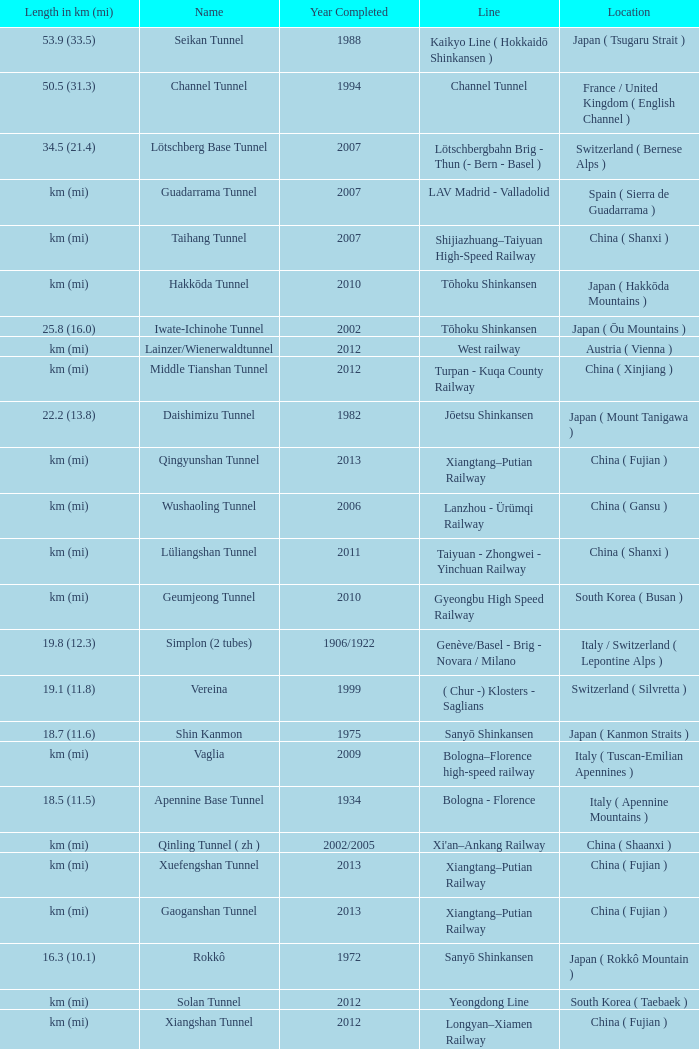Which line is the Geumjeong tunnel? Gyeongbu High Speed Railway. Parse the full table. {'header': ['Length in km (mi)', 'Name', 'Year Completed', 'Line', 'Location'], 'rows': [['53.9 (33.5)', 'Seikan Tunnel', '1988', 'Kaikyo Line ( Hokkaidō Shinkansen )', 'Japan ( Tsugaru Strait )'], ['50.5 (31.3)', 'Channel Tunnel', '1994', 'Channel Tunnel', 'France / United Kingdom ( English Channel )'], ['34.5 (21.4)', 'Lötschberg Base Tunnel', '2007', 'Lötschbergbahn Brig - Thun (- Bern - Basel )', 'Switzerland ( Bernese Alps )'], ['km (mi)', 'Guadarrama Tunnel', '2007', 'LAV Madrid - Valladolid', 'Spain ( Sierra de Guadarrama )'], ['km (mi)', 'Taihang Tunnel', '2007', 'Shijiazhuang–Taiyuan High-Speed Railway', 'China ( Shanxi )'], ['km (mi)', 'Hakkōda Tunnel', '2010', 'Tōhoku Shinkansen', 'Japan ( Hakkōda Mountains )'], ['25.8 (16.0)', 'Iwate-Ichinohe Tunnel', '2002', 'Tōhoku Shinkansen', 'Japan ( Ōu Mountains )'], ['km (mi)', 'Lainzer/Wienerwaldtunnel', '2012', 'West railway', 'Austria ( Vienna )'], ['km (mi)', 'Middle Tianshan Tunnel', '2012', 'Turpan - Kuqa County Railway', 'China ( Xinjiang )'], ['22.2 (13.8)', 'Daishimizu Tunnel', '1982', 'Jōetsu Shinkansen', 'Japan ( Mount Tanigawa )'], ['km (mi)', 'Qingyunshan Tunnel', '2013', 'Xiangtang–Putian Railway', 'China ( Fujian )'], ['km (mi)', 'Wushaoling Tunnel', '2006', 'Lanzhou - Ürümqi Railway', 'China ( Gansu )'], ['km (mi)', 'Lüliangshan Tunnel', '2011', 'Taiyuan - Zhongwei - Yinchuan Railway', 'China ( Shanxi )'], ['km (mi)', 'Geumjeong Tunnel', '2010', 'Gyeongbu High Speed Railway', 'South Korea ( Busan )'], ['19.8 (12.3)', 'Simplon (2 tubes)', '1906/1922', 'Genève/Basel - Brig - Novara / Milano', 'Italy / Switzerland ( Lepontine Alps )'], ['19.1 (11.8)', 'Vereina', '1999', '( Chur -) Klosters - Saglians', 'Switzerland ( Silvretta )'], ['18.7 (11.6)', 'Shin Kanmon', '1975', 'Sanyō Shinkansen', 'Japan ( Kanmon Straits )'], ['km (mi)', 'Vaglia', '2009', 'Bologna–Florence high-speed railway', 'Italy ( Tuscan-Emilian Apennines )'], ['18.5 (11.5)', 'Apennine Base Tunnel', '1934', 'Bologna - Florence', 'Italy ( Apennine Mountains )'], ['km (mi)', 'Qinling Tunnel ( zh )', '2002/2005', "Xi'an–Ankang Railway", 'China ( Shaanxi )'], ['km (mi)', 'Xuefengshan Tunnel', '2013', 'Xiangtang–Putian Railway', 'China ( Fujian )'], ['km (mi)', 'Gaoganshan Tunnel', '2013', 'Xiangtang–Putian Railway', 'China ( Fujian )'], ['16.3 (10.1)', 'Rokkô', '1972', 'Sanyō Shinkansen', 'Japan ( Rokkô Mountain )'], ['km (mi)', 'Solan Tunnel', '2012', 'Yeongdong Line', 'South Korea ( Taebaek )'], ['km (mi)', 'Xiangshan Tunnel', '2012', 'Longyan–Xiamen Railway', 'China ( Fujian )'], ['km (mi)', 'Daiyunshan Tunnel', '2013', 'Xiangtang–Putian Railway', 'China ( Fujian )'], ['km (mi)', 'Guanshan Tunnel', '2012', 'Tianshui - Pingliang Railway', 'China ( Gansu )'], ['15.4 (9.6)', 'Furka Base', '1982', 'Andermatt - Brig', 'Switzerland ( Urner Alps )'], ['15.4 (9.5)', 'Haruna', '1982', 'Jōetsu Shinkansen', 'Japan ( Gunma Prefecture )'], ['km (mi)', 'Firenzuola', '2009', 'Bologna–Florence high-speed railway', 'Italy ( Tuscan-Emilian Apennines )'], ['15.3 (9.5)', 'Severomuyskiy', '2001', 'Baikal Amur Mainline', 'Russia ( Severomuysky Range )'], ['15.2 (9.4)', 'Gorigamine', '1997', 'Nagano Shinkansen ( Hokuriku Shinkansen )', 'Japan ( Akaishi Mountains )'], ['km (mi)', 'Liulangshan Tunnel', '2012', 'Zhungeer - Shuozhou Railway', 'China ( Shanxi )'], ['15.0 (9.3)', 'Monte Santomarco', '1987', 'Paola - Cosenza', 'Italy ( Sila Mountains )'], ['15.0 (9.3)', 'Gotthard Rail Tunnel', '1882', 'Gotthardbahn Luzern / Zürich - Lugano - Milano', 'Switzerland ( Lepontine Alps )'], ['km (mi)', 'Maotianshan Tunnel', '2011', "Baotou - Xi'an Railway", 'China ( Shaanxi )'], ['14.9 (9.2)', 'Nakayama', '1982', 'Jōetsu Shinkansen', 'Japan ( Nakayama Pass )'], ['km (mi)', 'El Sargento #4', '1975', 'Tacna - Moquegua', 'Peru'], ['14.7 (9.1)', 'Mount Macdonald Tunnel', '1989', 'Calgary - Revelstoke', 'Canada ( Rogers Pass )'], ['km (mi)', 'Wuyishan Tunnel', '2013', 'Xiangtang–Putian Railway', 'China ( Fujian )'], ['14.6 (9.1)', 'Lötschberg', '1913', 'Lötschbergbahn Brig - Thun (- Bern - Basel )', 'Switzerland ( Bernese Alps )'], ['14.6 (9.1)', 'Romeriksporten', '1999', 'Gardermobanen', 'Norway ( Østmarka )'], ['km (mi)', 'Dayaoshan Tunnel ( zh )', '1987', 'Beijing - Guangzhou Railway', 'China ( Guangdong )'], ['km (mi)', 'Jinguashan Tunnel', '2013', 'Xiangtang–Putian Railway', 'China ( Fujian )'], ['13.9 (8.6)', 'Hokuriku', '1962', 'Hokuriku Main Line', 'Japan ( Mount Kinome )'], ['km (mi)', 'Yesanguan Tunnel', '2009', 'Yichang - Wanzhou Railway', 'China ( Hubei )'], ['km (mi)', 'North Tianshan Tunnel', '2009', 'Jinhe - Yining - Huo Erguosi Railway', 'China ( Xinjiang )'], ['km (mi)', 'Marmaray', '2013', 'Marmaray', 'Turkey ( Istanbul )'], ['13.5 (8.4)', 'Fréjus', '1871', 'Lyon - Turin', 'France ( Mont Cenis )'], ['13.5 (8.4)', 'Epping to Chatswood RailLink', '2009', 'Epping - Chatswood', 'Australia ( Sydney )'], ['13.5 (8.4)', 'Shin-Shimizu Tunnel', '1967', 'Jōetsu Line', 'Japan ( Mount Tanigawa )'], ['km (mi)', 'Hex River', '1989', 'Pretoria - Cape Town', 'South Africa ( Hex River Pass )'], ['km (mi)', 'Savio Rail Tunnel', '2008', 'Kerava - Vuosaari', 'Finland ( Uusimaa )'], ['km (mi)', 'Wonhyo Tunnel', '2010', 'Gyeongbu High Speed Railway', 'South Korea ( Ulsan )'], ['km (mi)', 'Dabieshan Tunnel', '2008', 'Hefei - Wuhan High Speed Railway', 'China ( Hubei )'], ['13.2 (8.2)', 'Schlern/Sciliar', '1993', 'Brenner Railway', 'Italy ( South Tyrol )'], ['13.1 (8.2)', 'Caponero-Capoverde', '2001', 'Genova-Ventimiglia', 'Italy'], ['13.0 (8.2)', 'Aki', '1975', 'Sanyo Shinkansen , Japan', 'Japan']]} 